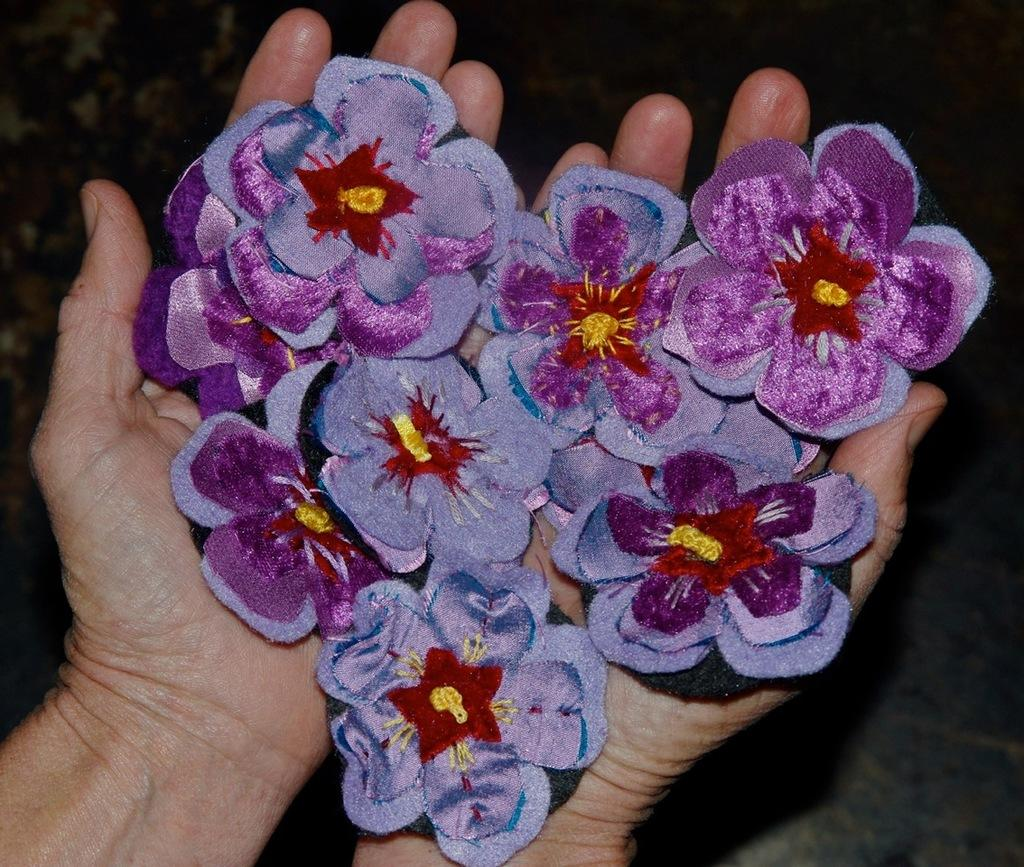What type of flowers are depicted in the image? The flowers in the image are made of cloth. Who is holding the cloth flowers? The flowers are in a person's hand. What color is the sign in the image? There is no sign present in the image. What type of vehicle is parked near the person holding the cloth flowers? There is no vehicle present in the image. 